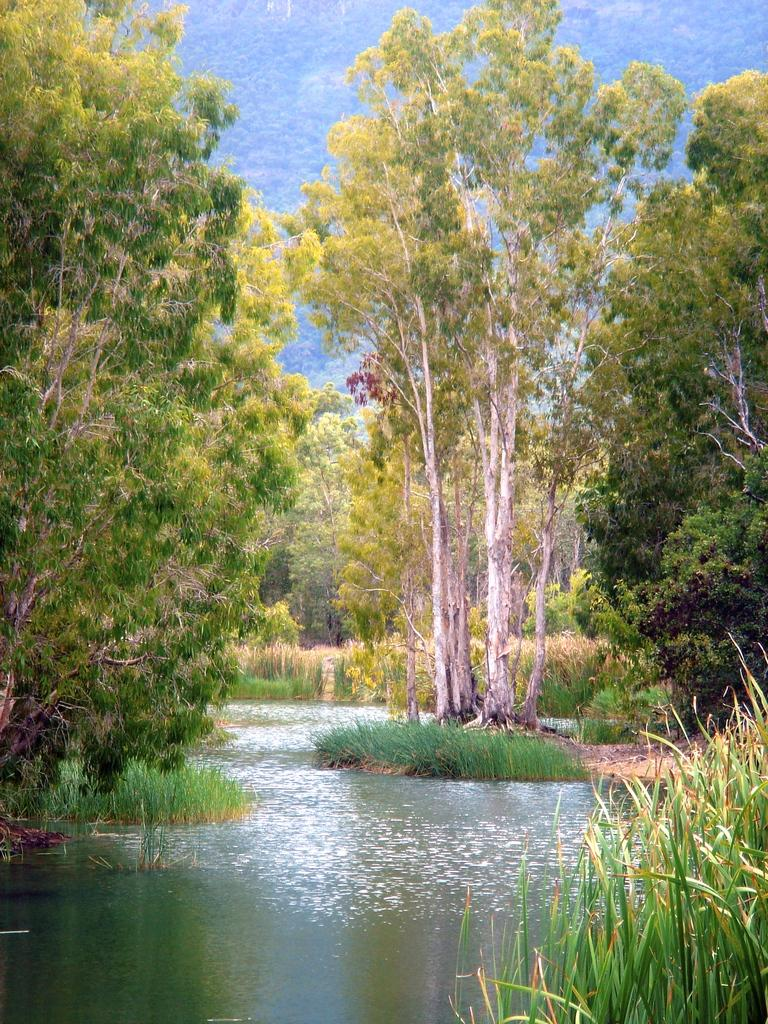What type of vegetation can be seen in the image? There are trees and plants in the image. What kind of landscape feature is present in the image? There are hills in the image. What can be seen at the bottom of the image? There is water visible at the bottom of the image. What color is the boy's hair in the image? There is no boy present in the image, so it is not possible to determine the color of his hair. 